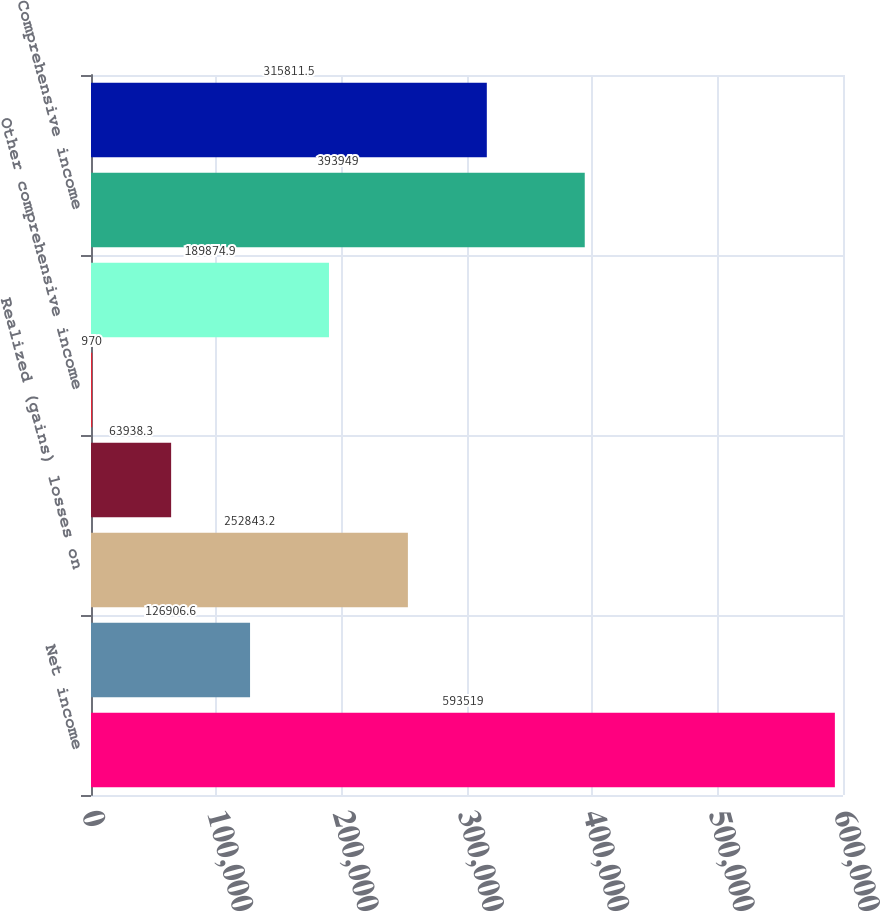Convert chart. <chart><loc_0><loc_0><loc_500><loc_500><bar_chart><fcel>Net income<fcel>Unrealized gains (losses) on<fcel>Realized (gains) losses on<fcel>Change in pension and<fcel>Other comprehensive income<fcel>Total other comprehensive<fcel>Comprehensive income<fcel>Less Comprehensive income<nl><fcel>593519<fcel>126907<fcel>252843<fcel>63938.3<fcel>970<fcel>189875<fcel>393949<fcel>315812<nl></chart> 